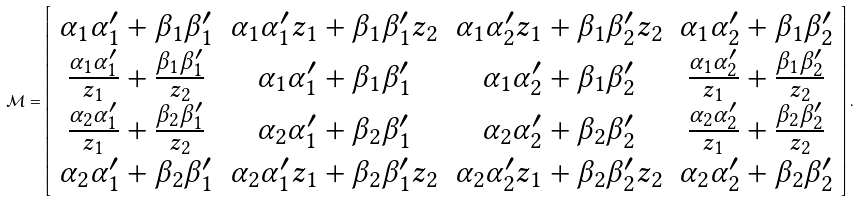Convert formula to latex. <formula><loc_0><loc_0><loc_500><loc_500>\mathcal { M } = \left [ \begin{array} { c c c c } \alpha _ { 1 } \alpha _ { 1 } ^ { \prime } + \beta _ { 1 } \beta _ { 1 } ^ { \prime } & \alpha _ { 1 } \alpha _ { 1 } ^ { \prime } z _ { 1 } + \beta _ { 1 } \beta _ { 1 } ^ { \prime } z _ { 2 } & \alpha _ { 1 } \alpha _ { 2 } ^ { \prime } z _ { 1 } + \beta _ { 1 } \beta _ { 2 } ^ { \prime } z _ { 2 } & \alpha _ { 1 } \alpha _ { 2 } ^ { \prime } + \beta _ { 1 } \beta _ { 2 } ^ { \prime } \\ \frac { \alpha _ { 1 } \alpha _ { 1 } ^ { \prime } } { z _ { 1 } } + \frac { \beta _ { 1 } \beta _ { 1 } ^ { \prime } } { z _ { 2 } } & \alpha _ { 1 } \alpha _ { 1 } ^ { \prime } + \beta _ { 1 } \beta _ { 1 } ^ { \prime } & \alpha _ { 1 } \alpha _ { 2 } ^ { \prime } + \beta _ { 1 } \beta _ { 2 } ^ { \prime } & \frac { \alpha _ { 1 } \alpha _ { 2 } ^ { \prime } } { z _ { 1 } } + \frac { \beta _ { 1 } \beta _ { 2 } ^ { \prime } } { z _ { 2 } } \\ \frac { \alpha _ { 2 } \alpha _ { 1 } ^ { \prime } } { z _ { 1 } } + \frac { \beta _ { 2 } \beta _ { 1 } ^ { \prime } } { z _ { 2 } } & \alpha _ { 2 } \alpha _ { 1 } ^ { \prime } + \beta _ { 2 } \beta _ { 1 } ^ { \prime } & \alpha _ { 2 } \alpha _ { 2 } ^ { \prime } + \beta _ { 2 } \beta _ { 2 } ^ { \prime } & \frac { \alpha _ { 2 } \alpha _ { 2 } ^ { \prime } } { z _ { 1 } } + \frac { \beta _ { 2 } \beta _ { 2 } ^ { \prime } } { z _ { 2 } } \\ \alpha _ { 2 } \alpha _ { 1 } ^ { \prime } + \beta _ { 2 } \beta _ { 1 } ^ { \prime } & \alpha _ { 2 } \alpha _ { 1 } ^ { \prime } z _ { 1 } + \beta _ { 2 } \beta _ { 1 } ^ { \prime } z _ { 2 } & \alpha _ { 2 } \alpha _ { 2 } ^ { \prime } z _ { 1 } + \beta _ { 2 } \beta _ { 2 } ^ { \prime } z _ { 2 } & \alpha _ { 2 } \alpha _ { 2 } ^ { \prime } + \beta _ { 2 } \beta _ { 2 } ^ { \prime } \end{array} \right ] .</formula> 